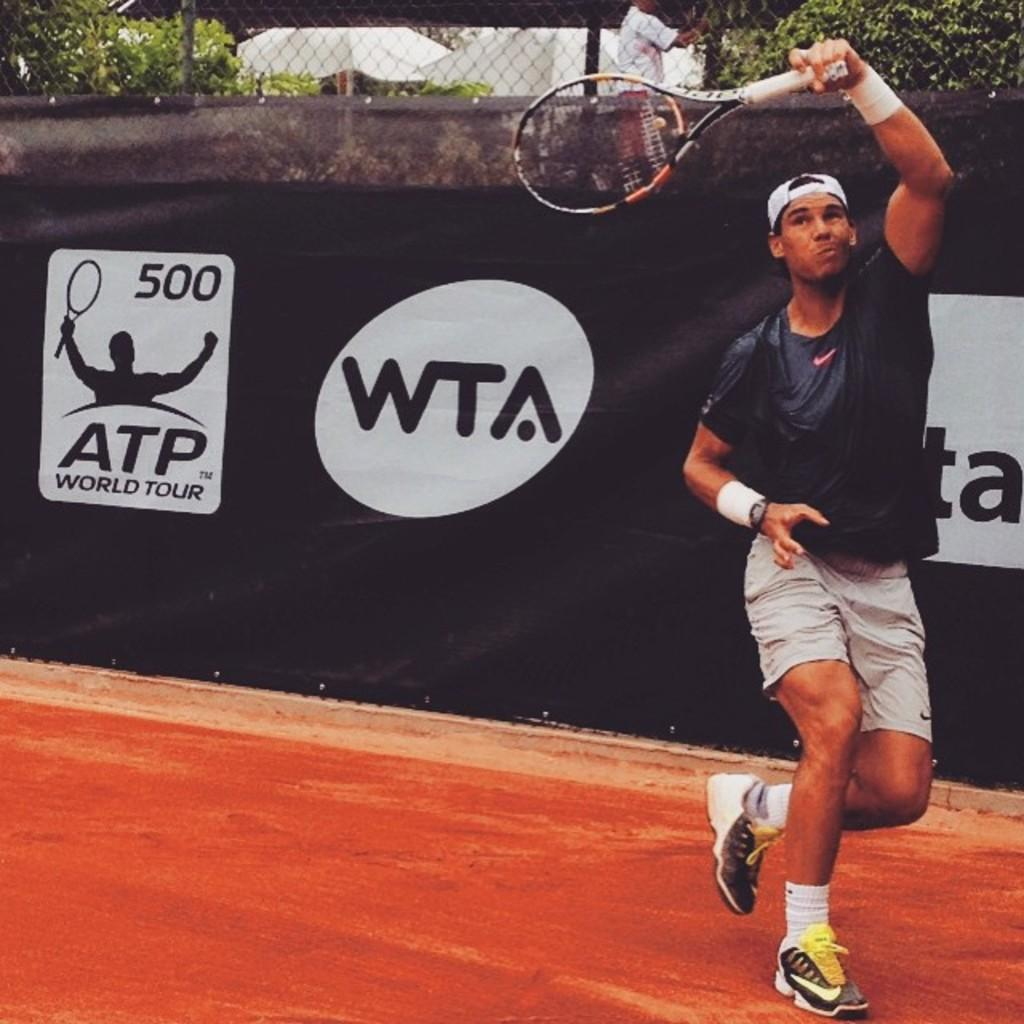Who is present in the image? There is a man in the image. What is the man holding in the image? The man is holding a tennis racket. Where is the man located in the image? The man is located in the bottom right side of the image. What else can be seen in the image besides the man? There is a banner, fencing, and trees in the image. What type of books can be seen on the desk in the image? There is no desk or books present in the image. 